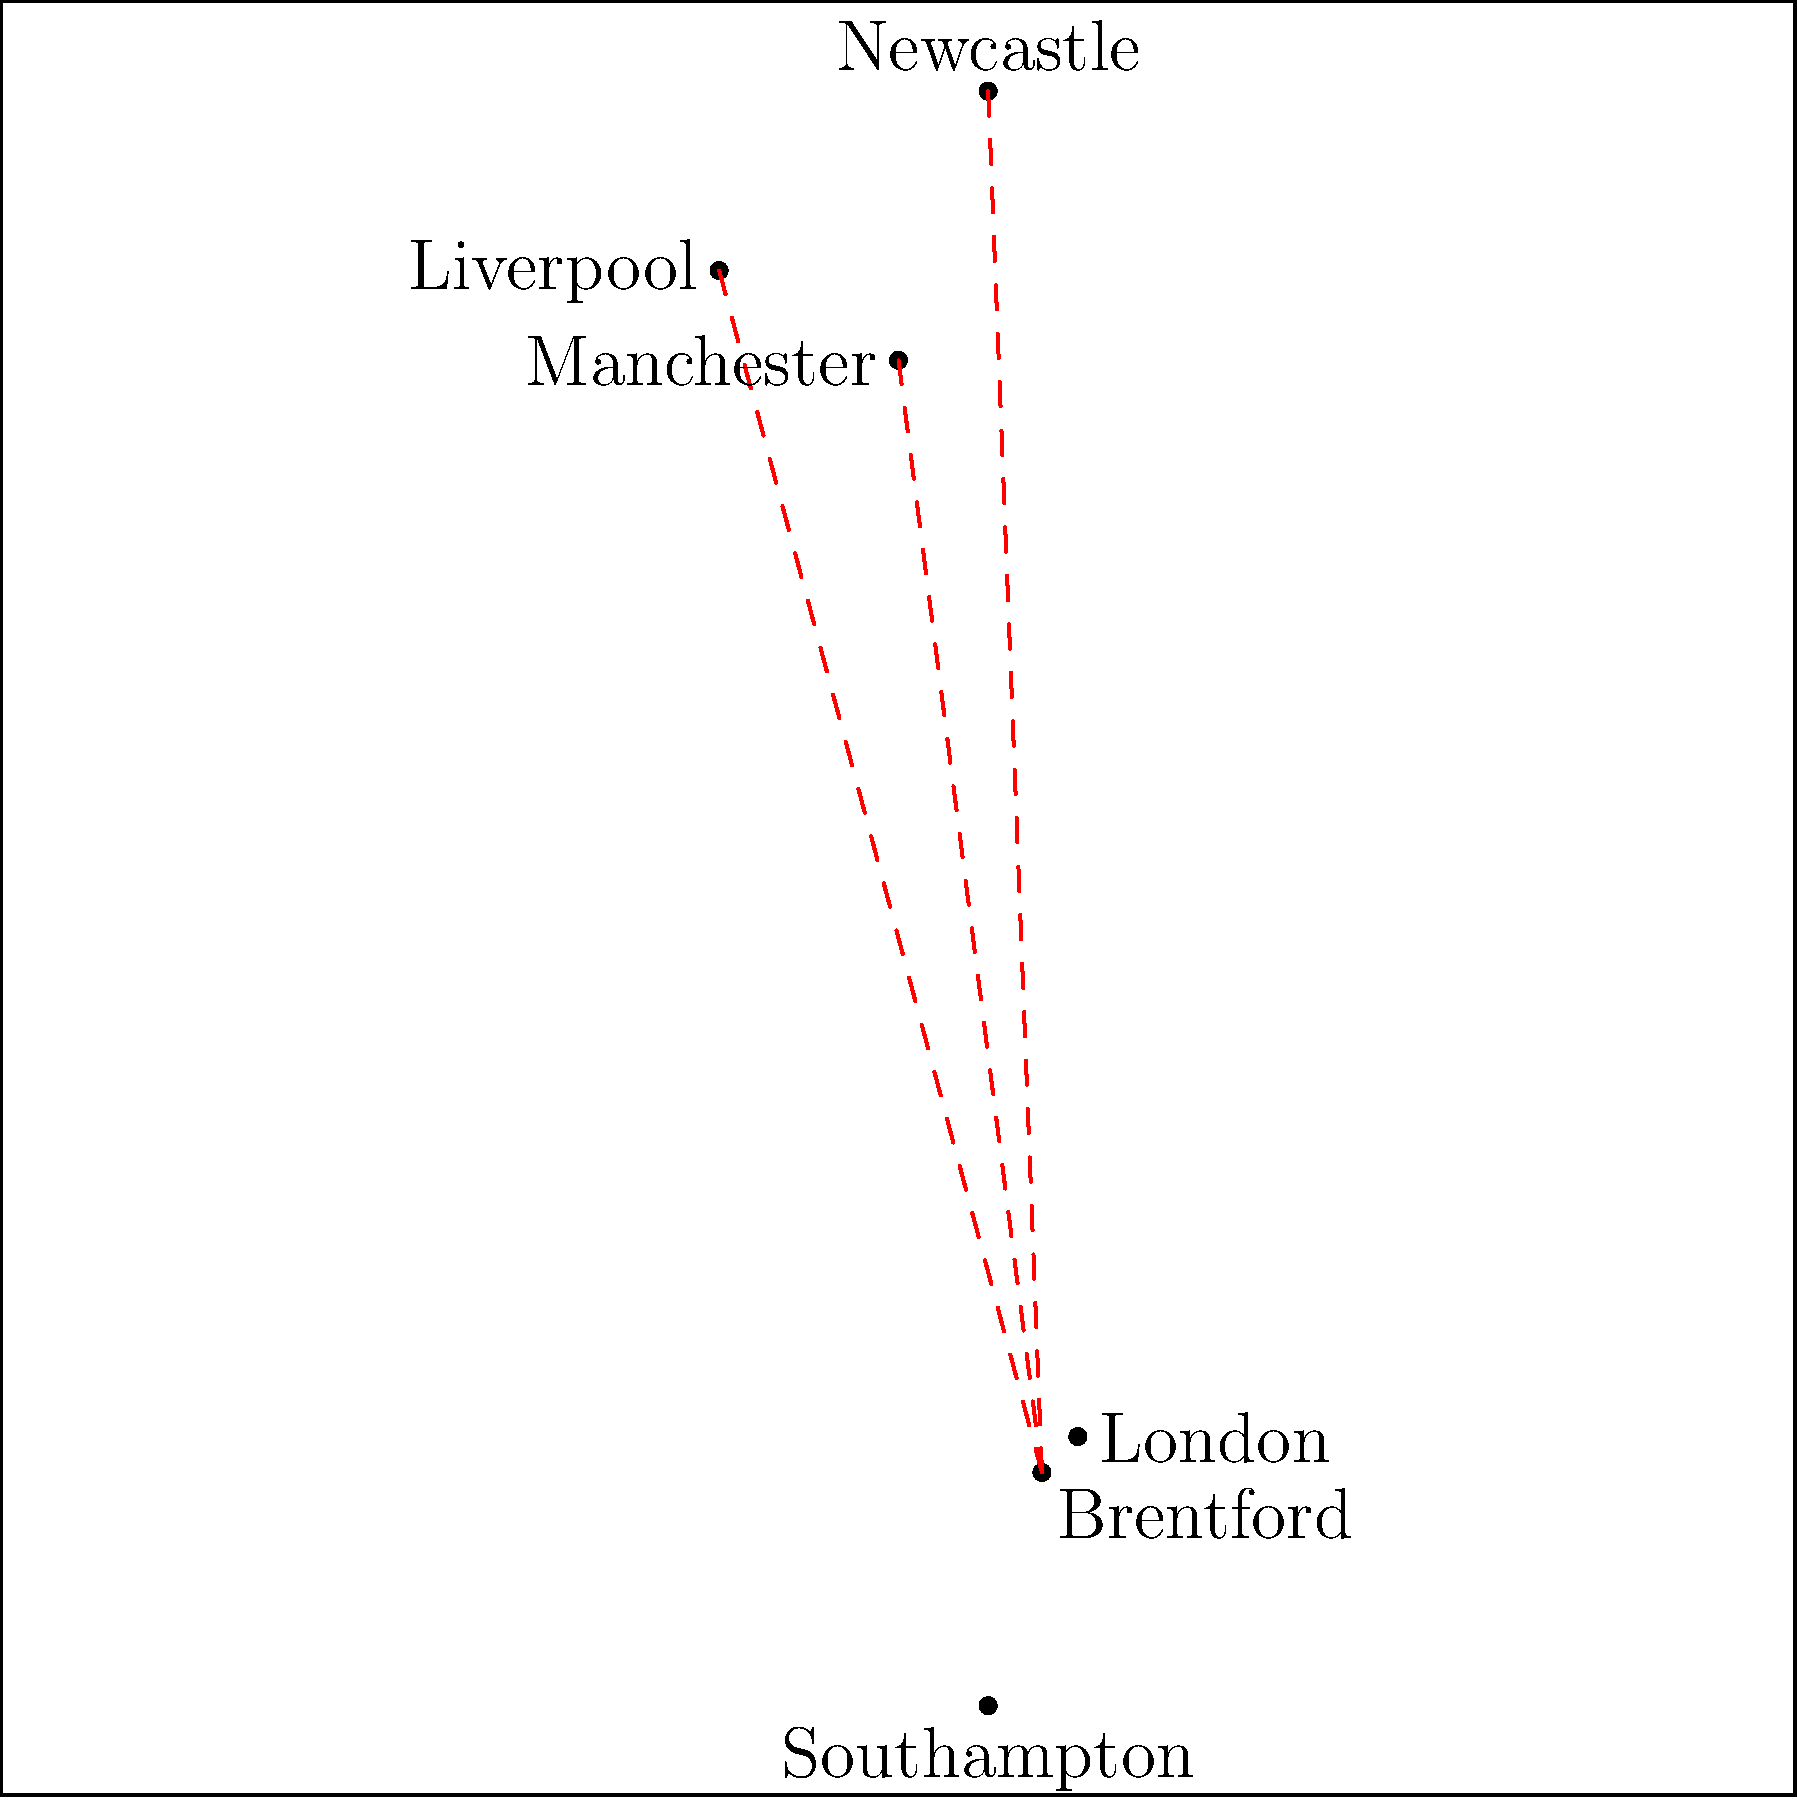As a dedicated Brentford FC supporter planning away game trips, which of the following cities is geographically closest to Brentford based on the map? To determine which city is geographically closest to Brentford, we need to compare the distances between Brentford and each of the given cities on the map. Let's analyze step-by-step:

1. Brentford's location: Near London in the southeast of England.

2. Distances to other cities:
   a) Manchester: Long distance, in the north of England.
   b) Liverpool: Even further north than Manchester.
   c) Newcastle: The furthest north on the map.
   d) Southampton: Relatively close, in the south of England.
   e) London: Very close to Brentford, almost adjacent on the map.

3. Visual comparison:
   - The red dashed lines show the long distances to northern cities.
   - No line is drawn to Southampton or London due to their proximity.

4. Conclusion:
   London is clearly the closest city to Brentford on the map.

This knowledge is crucial for a Brentford FC fan organizing watch parties and planning away game trips, as the distance to London would likely mean the shortest travel time and potentially more accessible matches for local supporters.
Answer: London 